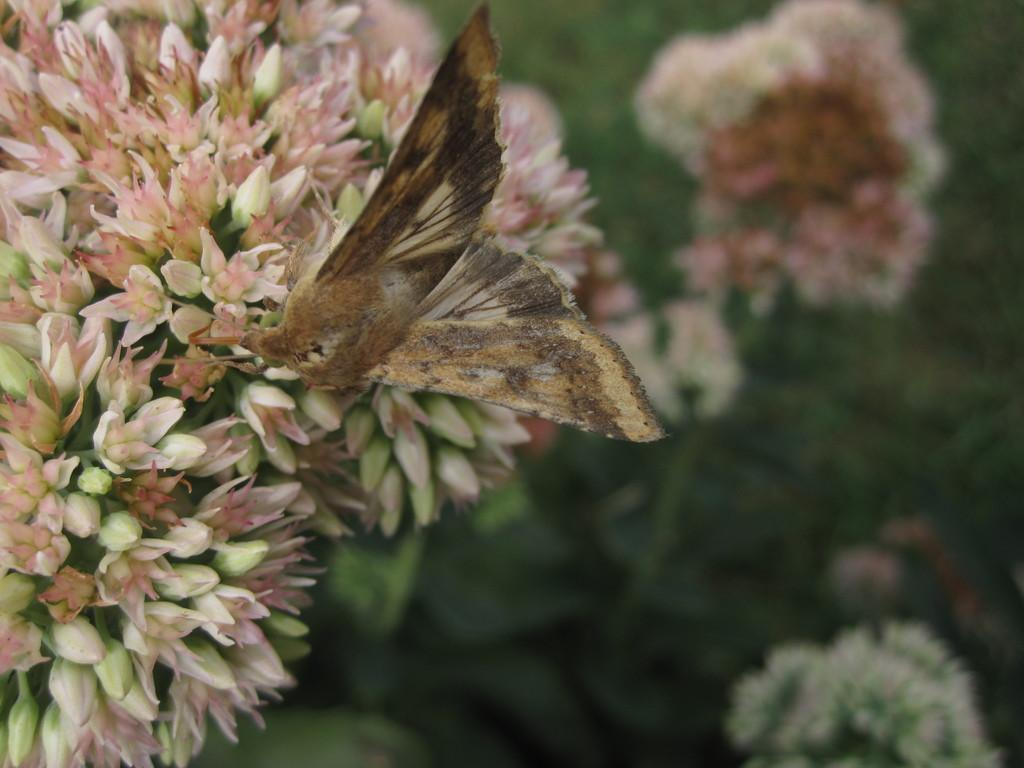What type of flora is present in the image? There are flowers in the image. Are there any animals or insects visible on the flowers? Yes, a butterfly is visible on the flowers. On which side of the image are the flowers located? The flowers are on the left side of the image. How many caps are being worn by the flowers in the image? There are no caps present in the image; it features flowers and a butterfly. 